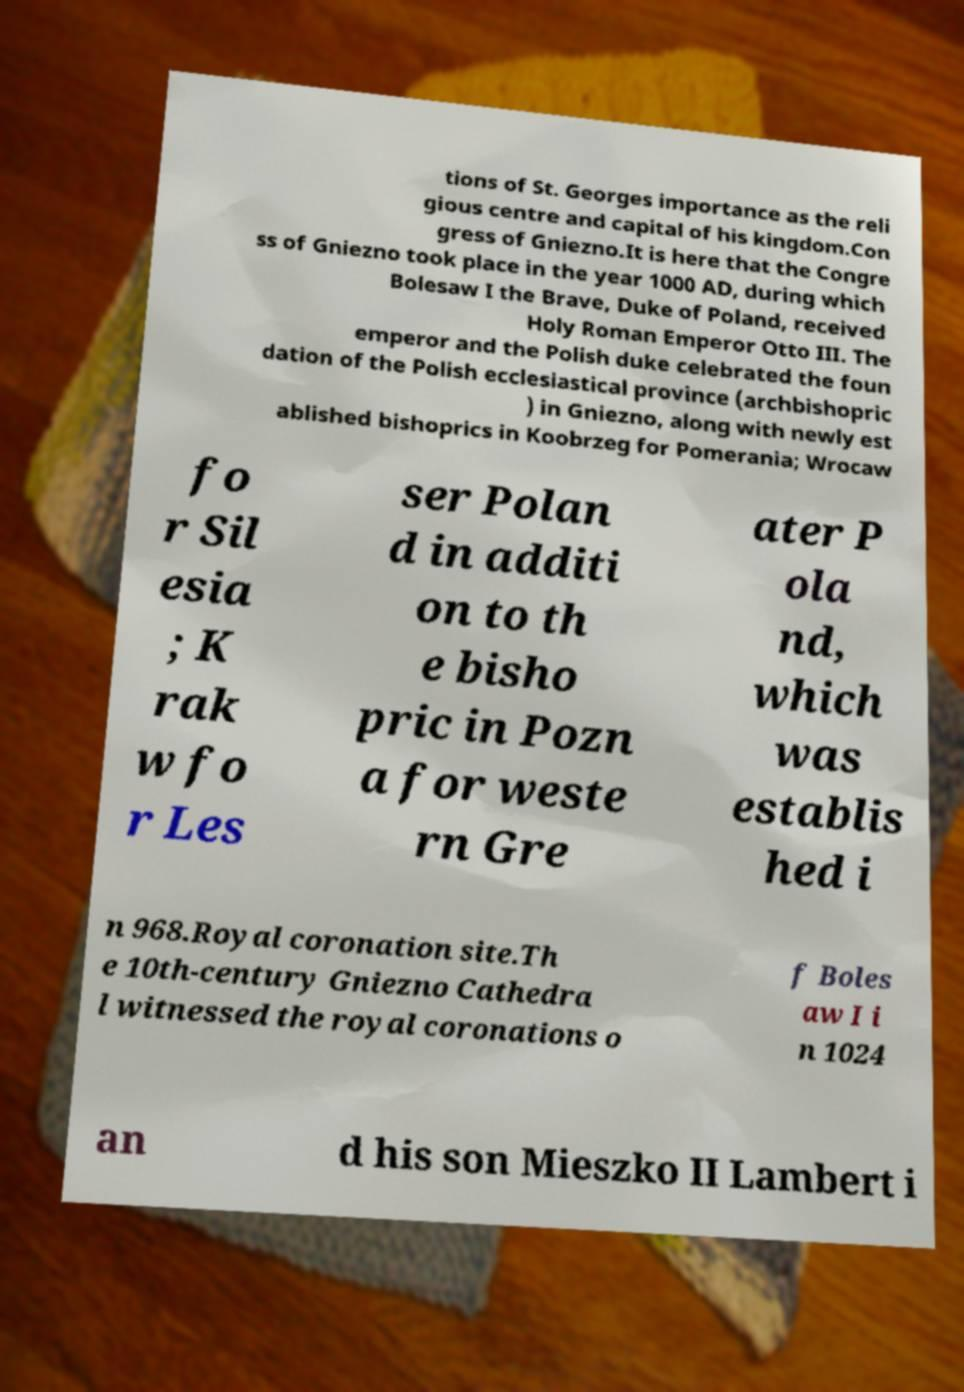Could you assist in decoding the text presented in this image and type it out clearly? tions of St. Georges importance as the reli gious centre and capital of his kingdom.Con gress of Gniezno.It is here that the Congre ss of Gniezno took place in the year 1000 AD, during which Bolesaw I the Brave, Duke of Poland, received Holy Roman Emperor Otto III. The emperor and the Polish duke celebrated the foun dation of the Polish ecclesiastical province (archbishopric ) in Gniezno, along with newly est ablished bishoprics in Koobrzeg for Pomerania; Wrocaw fo r Sil esia ; K rak w fo r Les ser Polan d in additi on to th e bisho pric in Pozn a for weste rn Gre ater P ola nd, which was establis hed i n 968.Royal coronation site.Th e 10th-century Gniezno Cathedra l witnessed the royal coronations o f Boles aw I i n 1024 an d his son Mieszko II Lambert i 